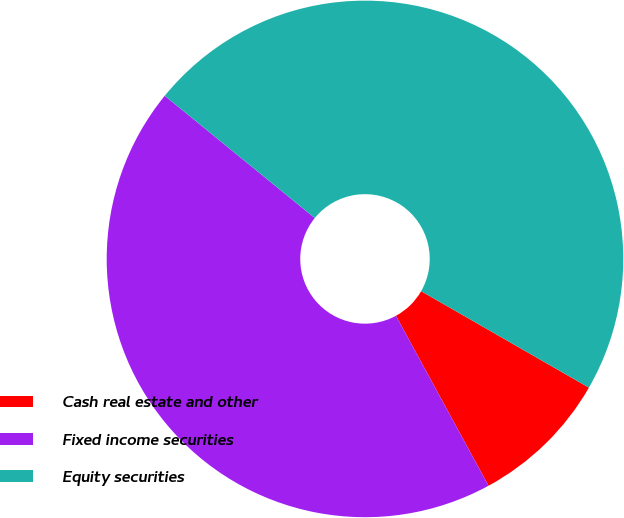<chart> <loc_0><loc_0><loc_500><loc_500><pie_chart><fcel>Cash real estate and other<fcel>Fixed income securities<fcel>Equity securities<nl><fcel>8.76%<fcel>43.82%<fcel>47.42%<nl></chart> 